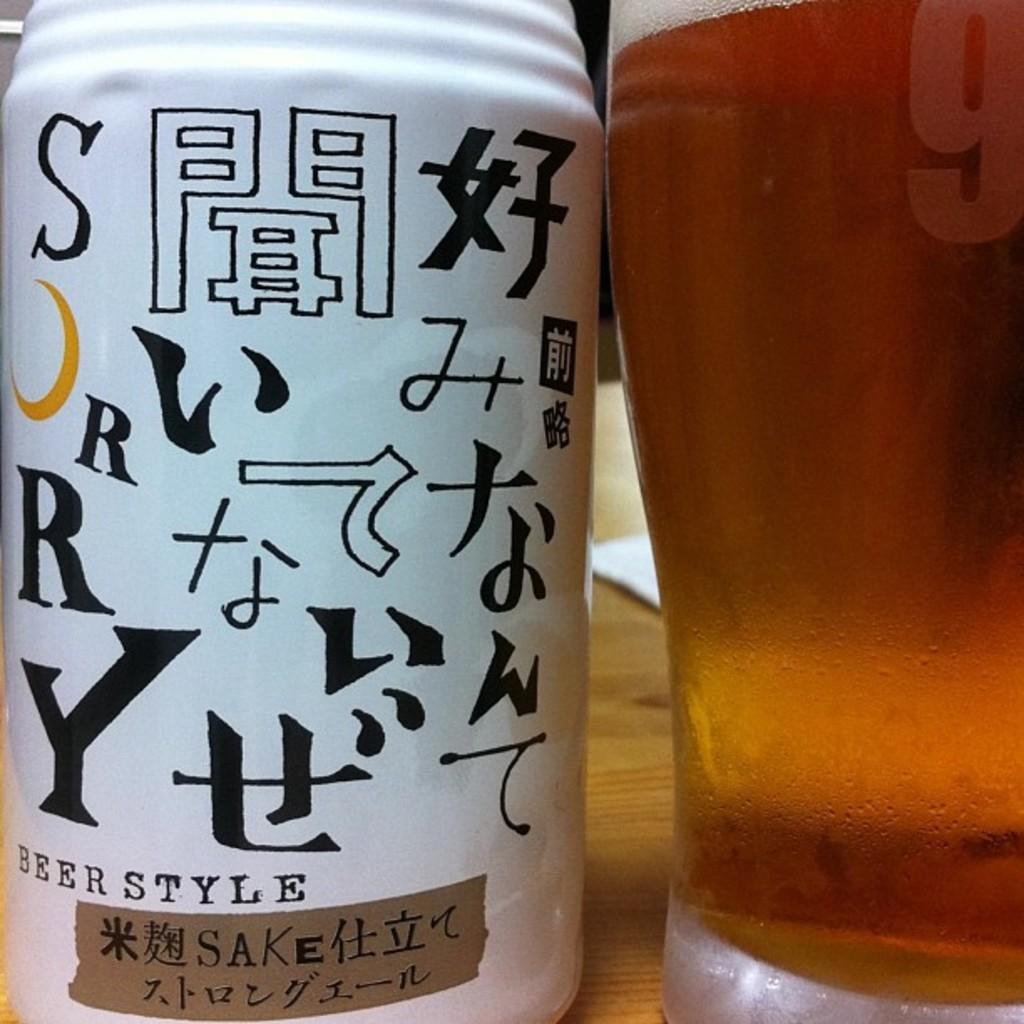<image>
Offer a succinct explanation of the picture presented. a white bobble that is labeled 'sorry beer style' in black 